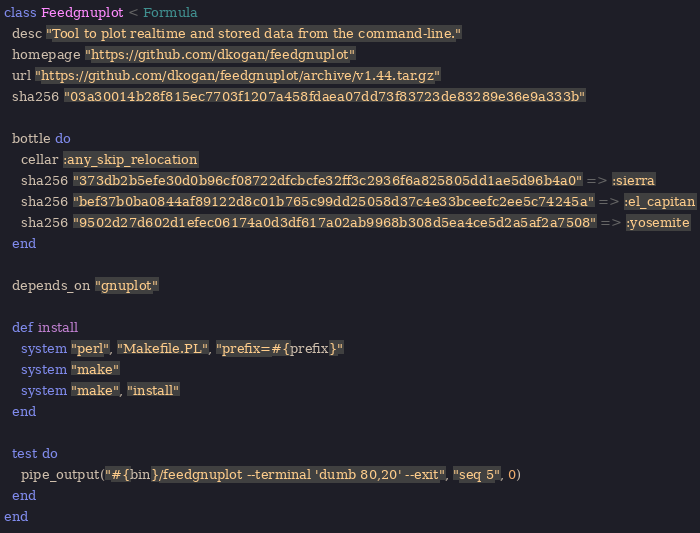<code> <loc_0><loc_0><loc_500><loc_500><_Ruby_>class Feedgnuplot < Formula
  desc "Tool to plot realtime and stored data from the command-line."
  homepage "https://github.com/dkogan/feedgnuplot"
  url "https://github.com/dkogan/feedgnuplot/archive/v1.44.tar.gz"
  sha256 "03a30014b28f815ec7703f1207a458fdaea07dd73f83723de83289e36e9a333b"

  bottle do
    cellar :any_skip_relocation
    sha256 "373db2b5efe30d0b96cf08722dfcbcfe32ff3c2936f6a825805dd1ae5d96b4a0" => :sierra
    sha256 "bef37b0ba0844af89122d8c01b765c99dd25058d37c4e33bceefc2ee5c74245a" => :el_capitan
    sha256 "9502d27d602d1efec06174a0d3df617a02ab9968b308d5ea4ce5d2a5af2a7508" => :yosemite
  end

  depends_on "gnuplot"

  def install
    system "perl", "Makefile.PL", "prefix=#{prefix}"
    system "make"
    system "make", "install"
  end

  test do
    pipe_output("#{bin}/feedgnuplot --terminal 'dumb 80,20' --exit", "seq 5", 0)
  end
end
</code> 